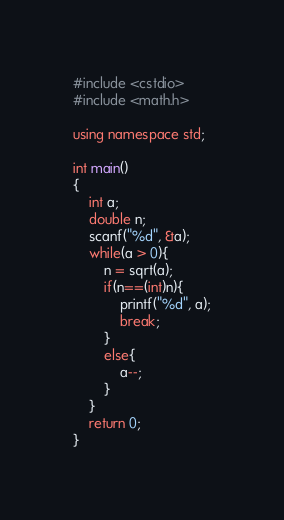<code> <loc_0><loc_0><loc_500><loc_500><_C++_>#include <cstdio>
#include <math.h>

using namespace std;

int main()
{
    int a;
    double n;
    scanf("%d", &a);
    while(a > 0){
        n = sqrt(a);
        if(n==(int)n){
            printf("%d", a);
            break;
        }
        else{
            a--;
        }
    }
    return 0;
}
</code> 